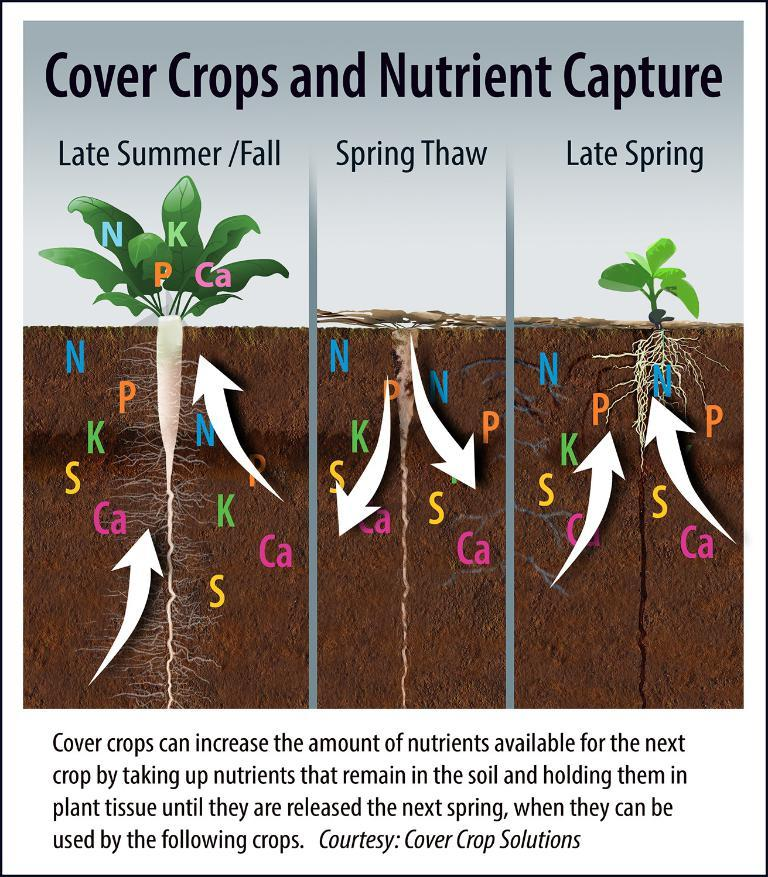What is depicted on the paper in the image? The paper contains a drawing of a plant. What specific part of the plant is included in the drawing? The drawing includes roots. Is there any text on the paper? Yes, there is writing on the paper. What type of watch is being worn by the plant in the image? There is no watch present in the image. The image features a paper with a drawing of a plant and writing on it. 